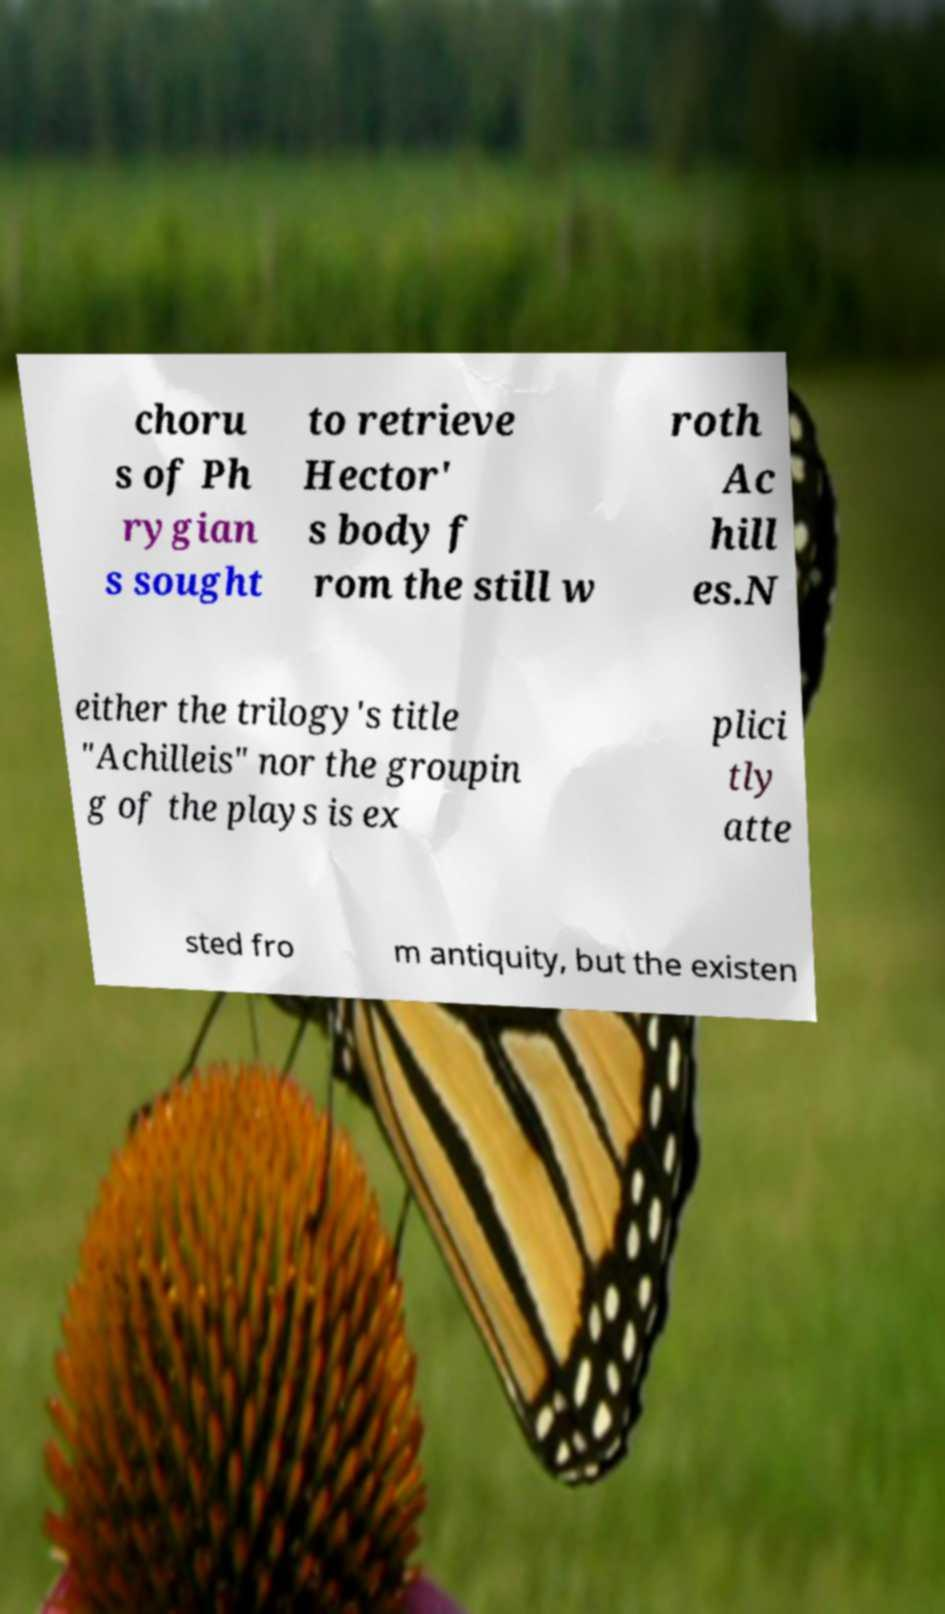Please identify and transcribe the text found in this image. choru s of Ph rygian s sought to retrieve Hector' s body f rom the still w roth Ac hill es.N either the trilogy's title "Achilleis" nor the groupin g of the plays is ex plici tly atte sted fro m antiquity, but the existen 